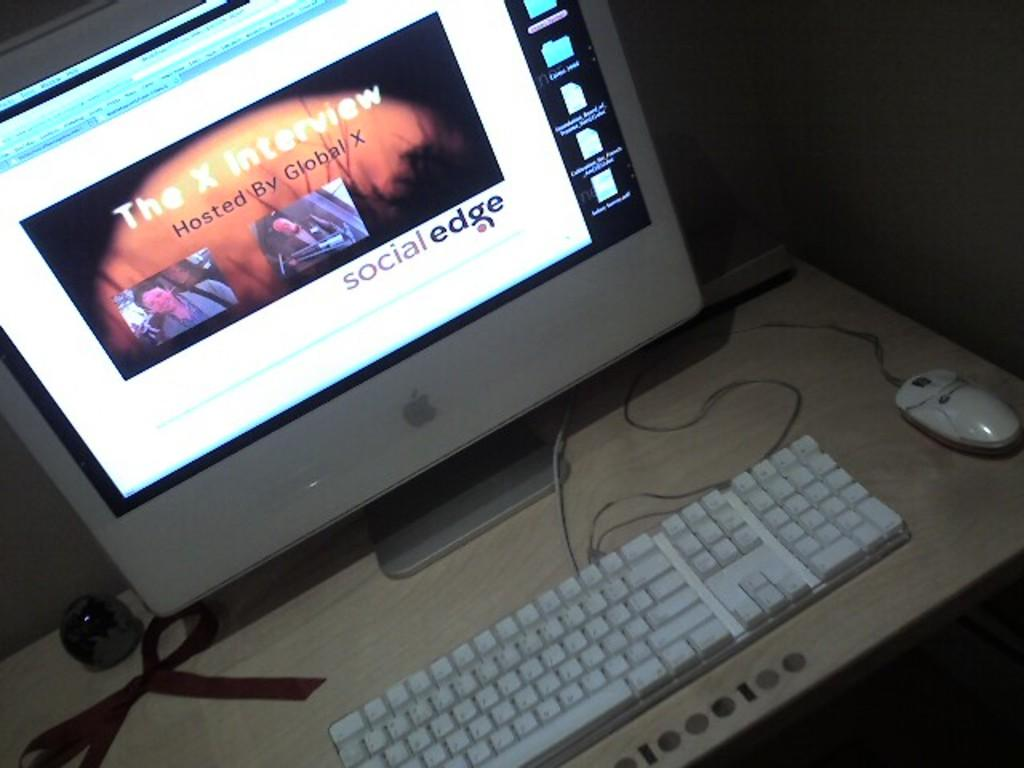What activity are the people in the image engaged in? The people in the image are standing near a river. What objects are the people holding? The people are holding fishing rods. Can you describe the location of the people in the image? The people are standing near a river. What type of pies are being served at the event in the image? There is no event or pies present in the image; it features a group of people standing near a river with fishing rods. What topic are the people discussing in the image? There is no discussion or talk happening in the image; the people are holding fishing rods and standing near a river. 